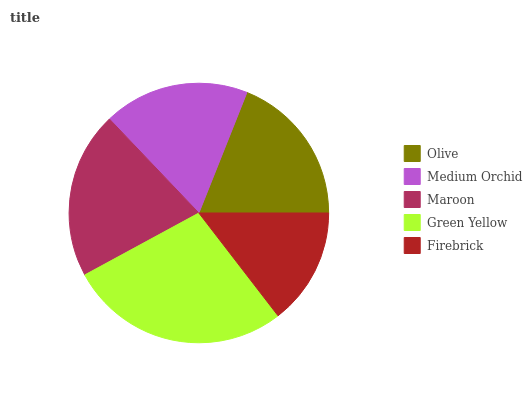Is Firebrick the minimum?
Answer yes or no. Yes. Is Green Yellow the maximum?
Answer yes or no. Yes. Is Medium Orchid the minimum?
Answer yes or no. No. Is Medium Orchid the maximum?
Answer yes or no. No. Is Olive greater than Medium Orchid?
Answer yes or no. Yes. Is Medium Orchid less than Olive?
Answer yes or no. Yes. Is Medium Orchid greater than Olive?
Answer yes or no. No. Is Olive less than Medium Orchid?
Answer yes or no. No. Is Olive the high median?
Answer yes or no. Yes. Is Olive the low median?
Answer yes or no. Yes. Is Medium Orchid the high median?
Answer yes or no. No. Is Firebrick the low median?
Answer yes or no. No. 